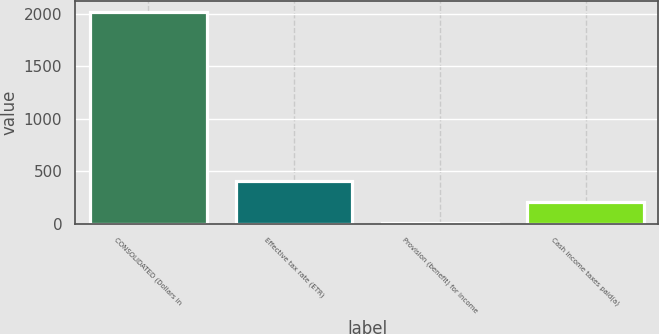Convert chart to OTSL. <chart><loc_0><loc_0><loc_500><loc_500><bar_chart><fcel>CONSOLIDATED (Dollars in<fcel>Effective tax rate (ETR)<fcel>Provision (benefit) for income<fcel>Cash income taxes paid(a)<nl><fcel>2016<fcel>404.08<fcel>1.1<fcel>202.59<nl></chart> 